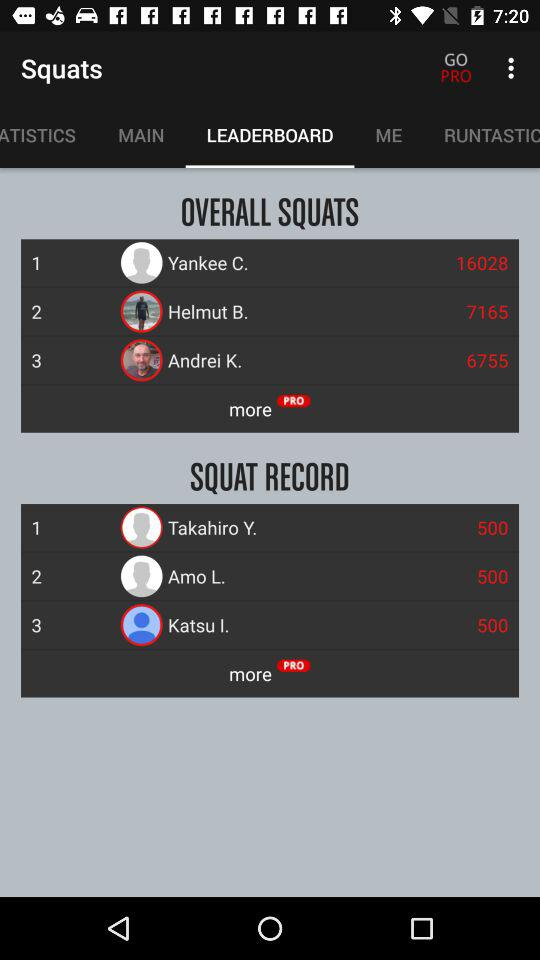What is the overall squat of Yankee C.? The overall squat of Yankee C. is 16028. 